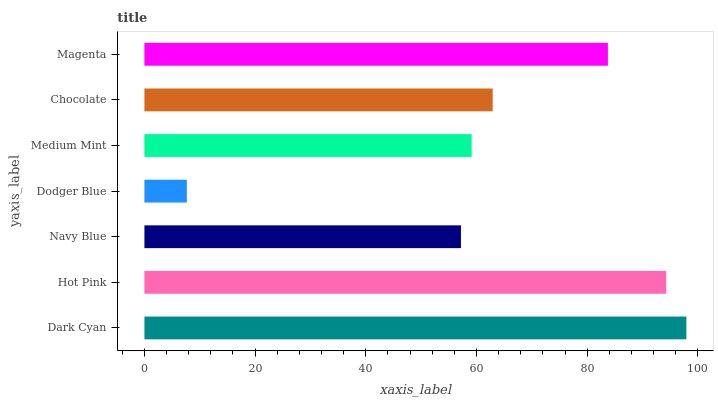Is Dodger Blue the minimum?
Answer yes or no. Yes. Is Dark Cyan the maximum?
Answer yes or no. Yes. Is Hot Pink the minimum?
Answer yes or no. No. Is Hot Pink the maximum?
Answer yes or no. No. Is Dark Cyan greater than Hot Pink?
Answer yes or no. Yes. Is Hot Pink less than Dark Cyan?
Answer yes or no. Yes. Is Hot Pink greater than Dark Cyan?
Answer yes or no. No. Is Dark Cyan less than Hot Pink?
Answer yes or no. No. Is Chocolate the high median?
Answer yes or no. Yes. Is Chocolate the low median?
Answer yes or no. Yes. Is Magenta the high median?
Answer yes or no. No. Is Dark Cyan the low median?
Answer yes or no. No. 